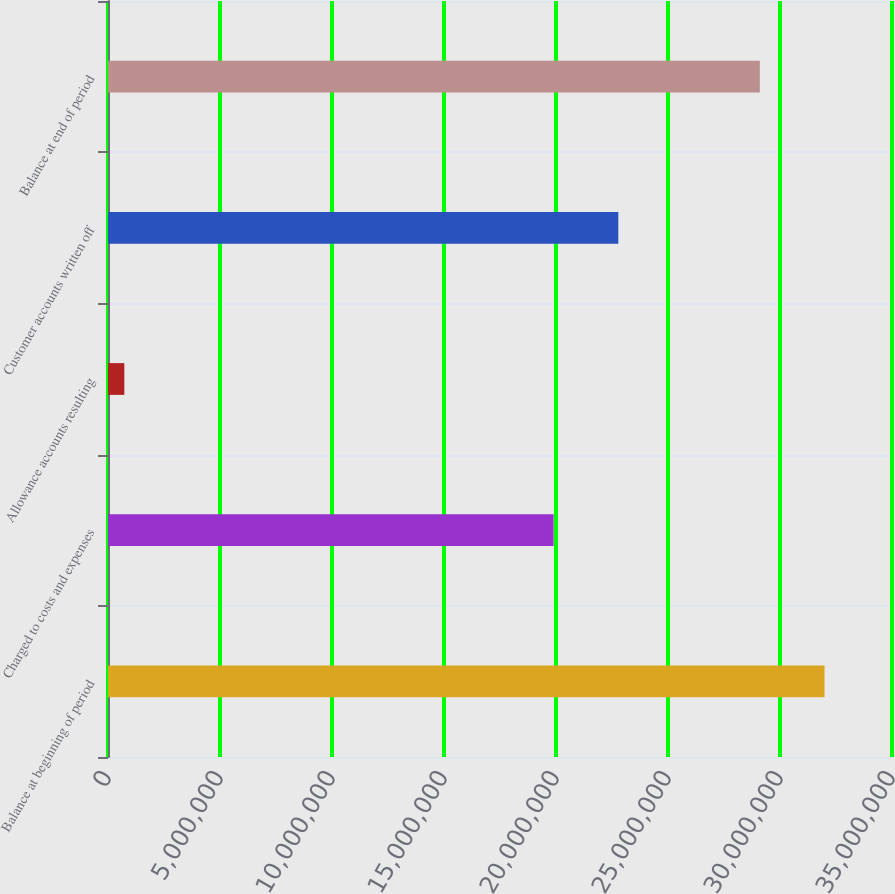Convert chart. <chart><loc_0><loc_0><loc_500><loc_500><bar_chart><fcel>Balance at beginning of period<fcel>Charged to costs and expenses<fcel>Allowance accounts resulting<fcel>Customer accounts written off<fcel>Balance at end of period<nl><fcel>3.19875e+07<fcel>1.9895e+07<fcel>729000<fcel>2.27825e+07<fcel>2.91e+07<nl></chart> 